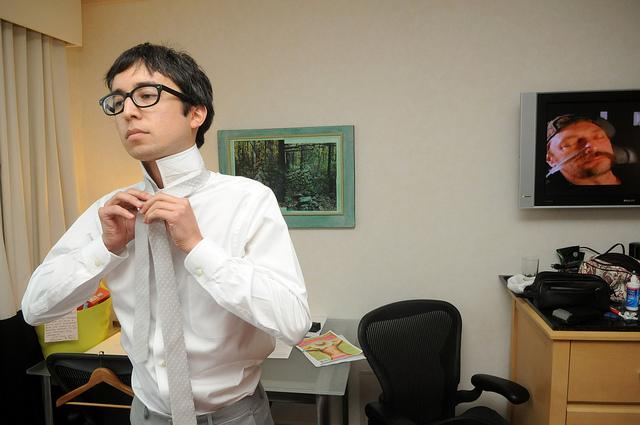What color theme is the man with the the tie trying to achieve with his outfit?

Choices:
A) white
B) blue
C) black
D) grey grey 